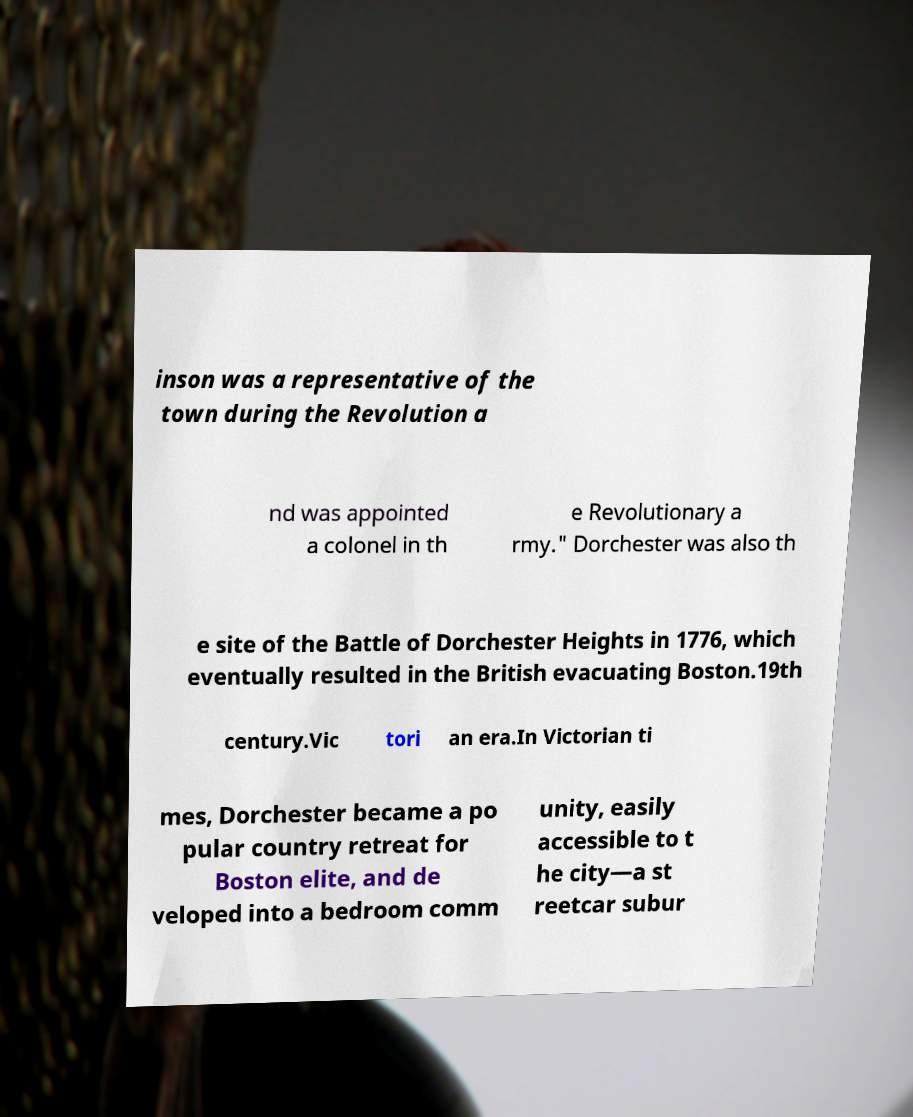I need the written content from this picture converted into text. Can you do that? inson was a representative of the town during the Revolution a nd was appointed a colonel in th e Revolutionary a rmy." Dorchester was also th e site of the Battle of Dorchester Heights in 1776, which eventually resulted in the British evacuating Boston.19th century.Vic tori an era.In Victorian ti mes, Dorchester became a po pular country retreat for Boston elite, and de veloped into a bedroom comm unity, easily accessible to t he city—a st reetcar subur 